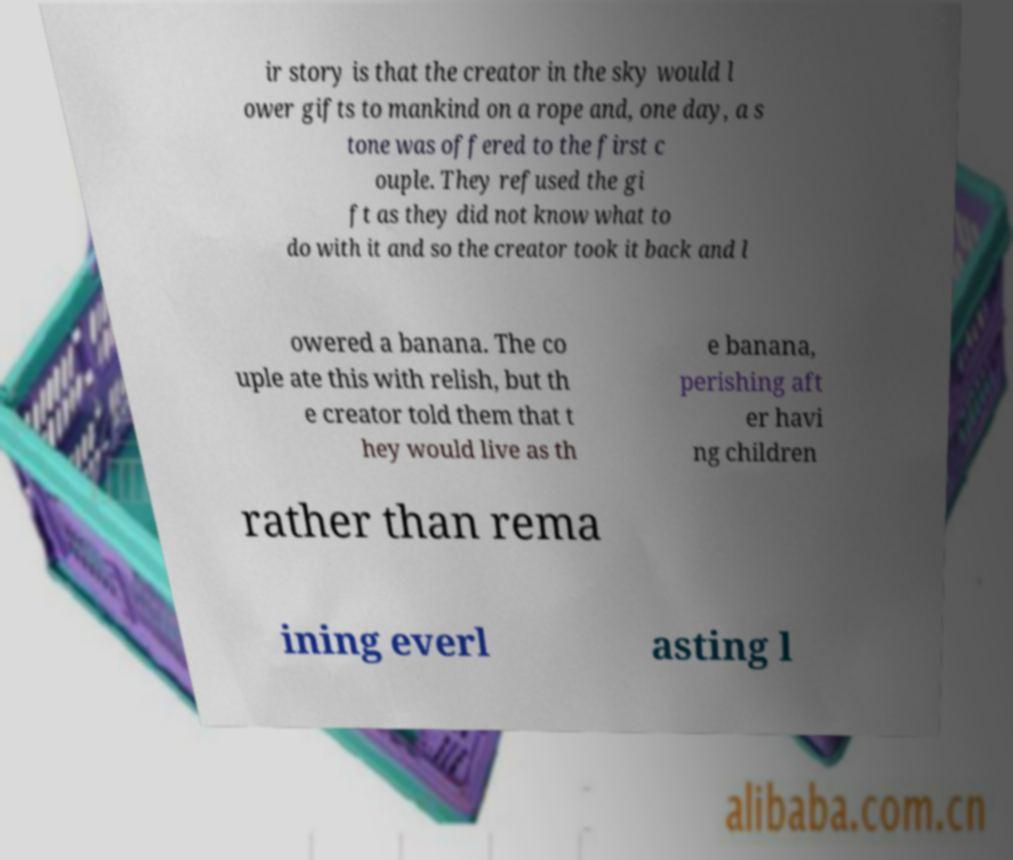Please read and relay the text visible in this image. What does it say? ir story is that the creator in the sky would l ower gifts to mankind on a rope and, one day, a s tone was offered to the first c ouple. They refused the gi ft as they did not know what to do with it and so the creator took it back and l owered a banana. The co uple ate this with relish, but th e creator told them that t hey would live as th e banana, perishing aft er havi ng children rather than rema ining everl asting l 